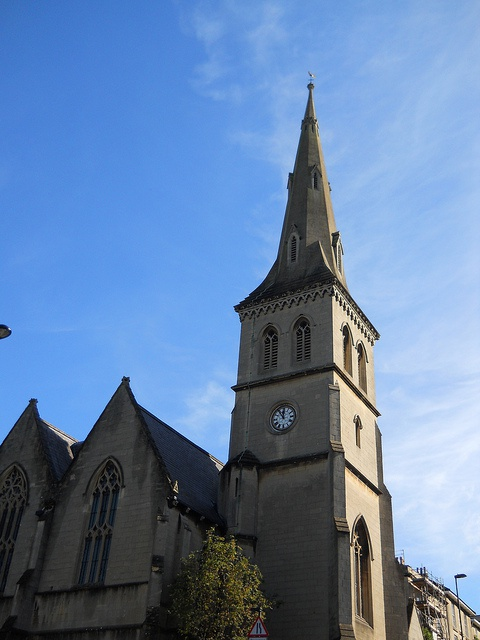Describe the objects in this image and their specific colors. I can see a clock in blue, black, and gray tones in this image. 